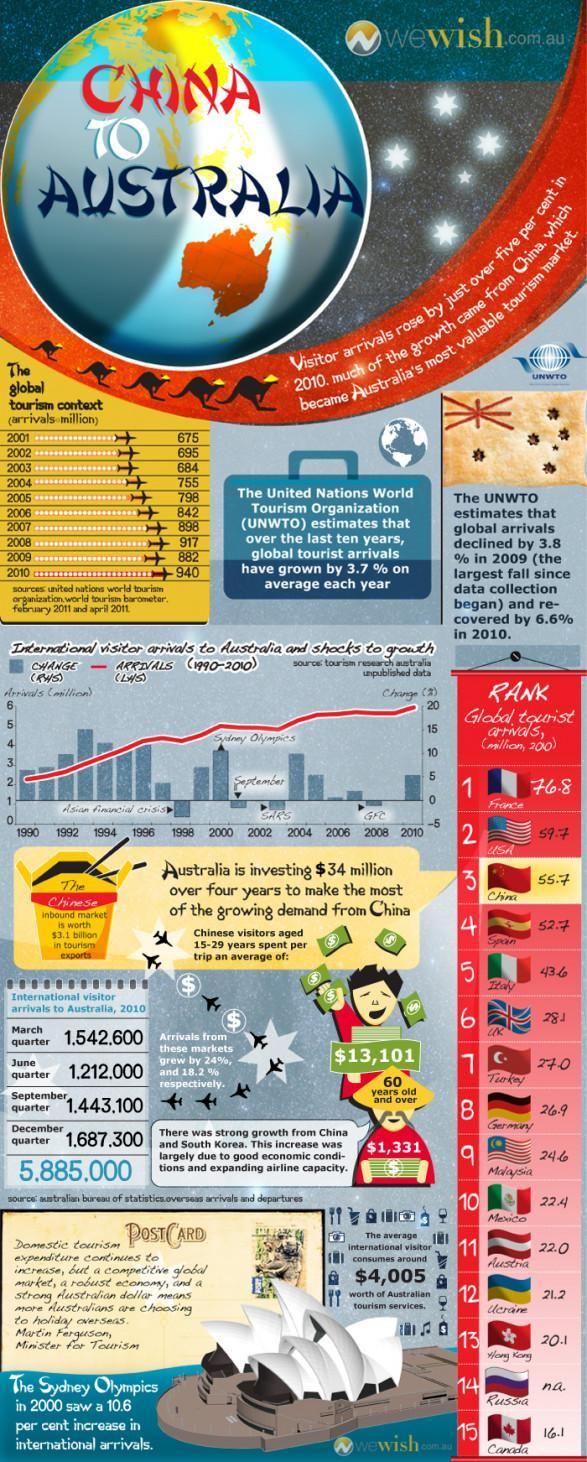Which year had the most tourism arrivals?
Answer the question with a short phrase. 2010 How many flags are shown under RANK? 15 Which quarter had the highest number of international visitors in 2010? December quarter What was the total number of international visitors in all quarters during 2010? 5,885,000 Due to what there was a change in international visitor arrival during 2002-2004? SARS How much do senior citizens from China spent per trip on an average? $1,331 How many international visitors came during June and September quarters? 2,655,100 By what number did tourists increase from 2001 to 2010? 265 million 